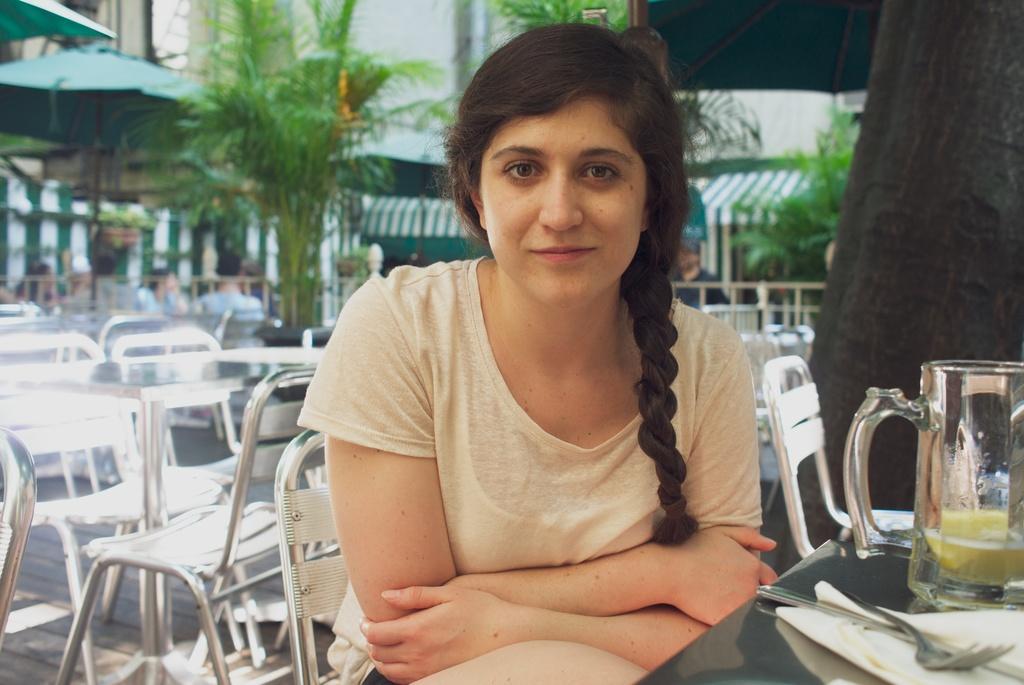In one or two sentences, can you explain what this image depicts? The woman is sitting in a chair in front of a table which has glass,fork,tissue on it and there are some empty chairs left in the background. 